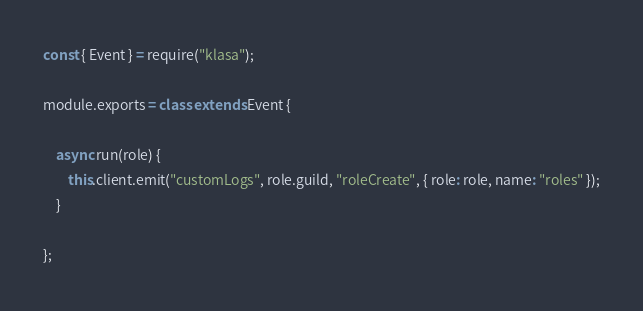Convert code to text. <code><loc_0><loc_0><loc_500><loc_500><_JavaScript_>const { Event } = require("klasa");

module.exports = class extends Event {

    async run(role) {
        this.client.emit("customLogs", role.guild, "roleCreate", { role: role, name: "roles" });
    }

};
</code> 